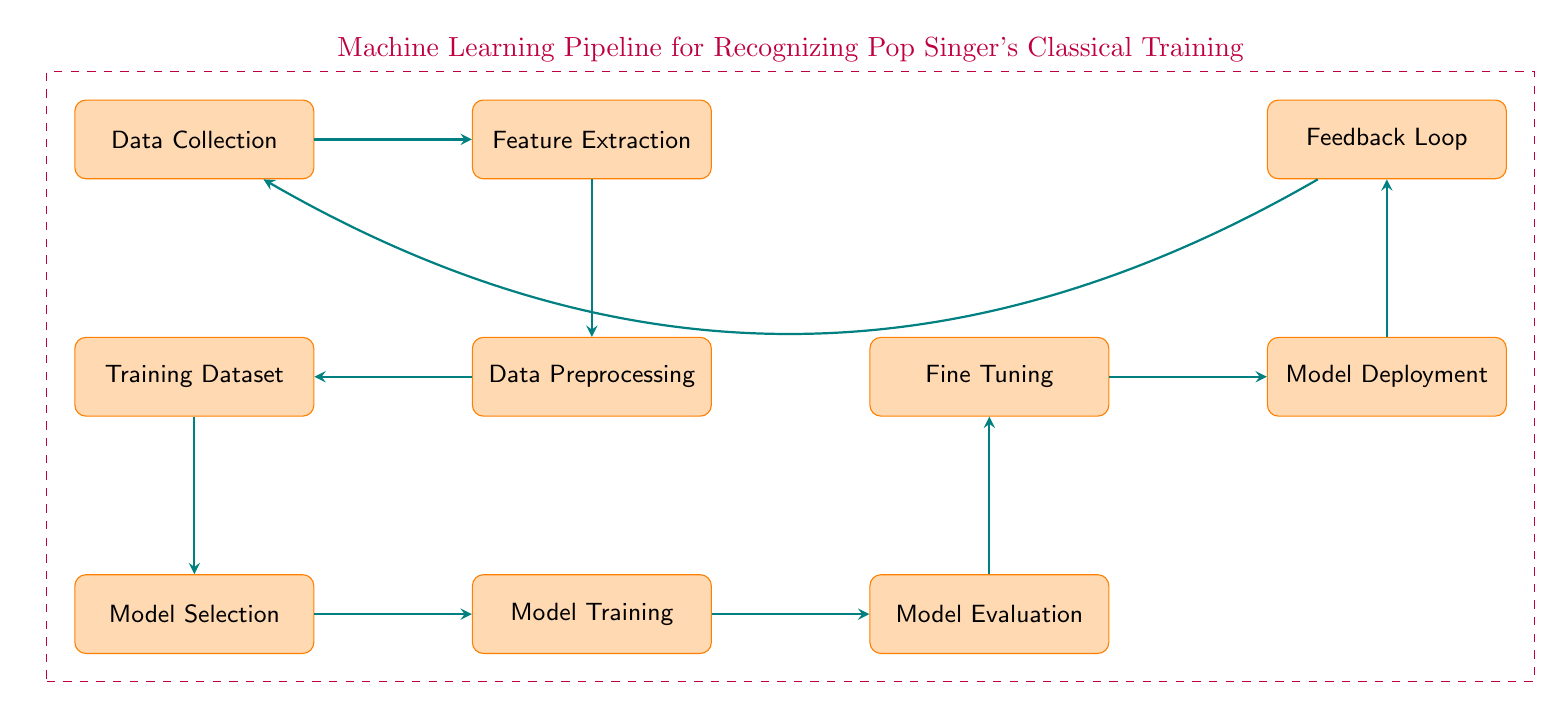What is the first step in the machine learning pipeline? The first step in the pipeline, as indicated in the diagram, is labeled 'Data Collection', which is positioned at the top left corner.
Answer: Data Collection How many processes are in the machine learning pipeline? By counting all the individual processes represented in the diagram, there are a total of nine processes connected in the pipeline.
Answer: Nine What follows 'Feature Extraction' in the diagram? The next process that occurs after 'Feature Extraction' is 'Data Preprocessing', which is directly below it in the flow of the diagram.
Answer: Data Preprocessing What process is located to the right of 'Model Training'? Located directly to the right of 'Model Training' is 'Model Evaluation', which is the next step taken after training the model.
Answer: Model Evaluation Which process leads to 'Model Deployment'? The process that leads directly to 'Model Deployment' is 'Fine Tuning', as indicated by the arrow connecting these two processes in the diagram.
Answer: Fine Tuning Describe the relationship between 'Training Dataset' and 'Model Selection'. 'Training Dataset' is a specific input required for 'Model Selection'; in the diagram, the arrow indicates that one directs into the other, signifying that the training dataset informs the model selection process.
Answer: Input How does the feedback loop interact with the first step? The feedback loop, indicated in the diagram, arrows back to 'Data Collection', demonstrating how feedback is utilized to revisit the initial step for potential improvement in data collection.
Answer: Improvement What is the final process in the machine learning pipeline? The last process in the machine learning pipeline is 'Feedback Loop', which reflects the cyclic nature of the process and ensures continual refinement based on results.
Answer: Feedback Loop Which processes are side by side in the diagram? 'Model Training' and 'Model Evaluation' are side by side in the diagram, indicating that after training a model, it is then evaluated for performance.
Answer: Model Training and Model Evaluation 